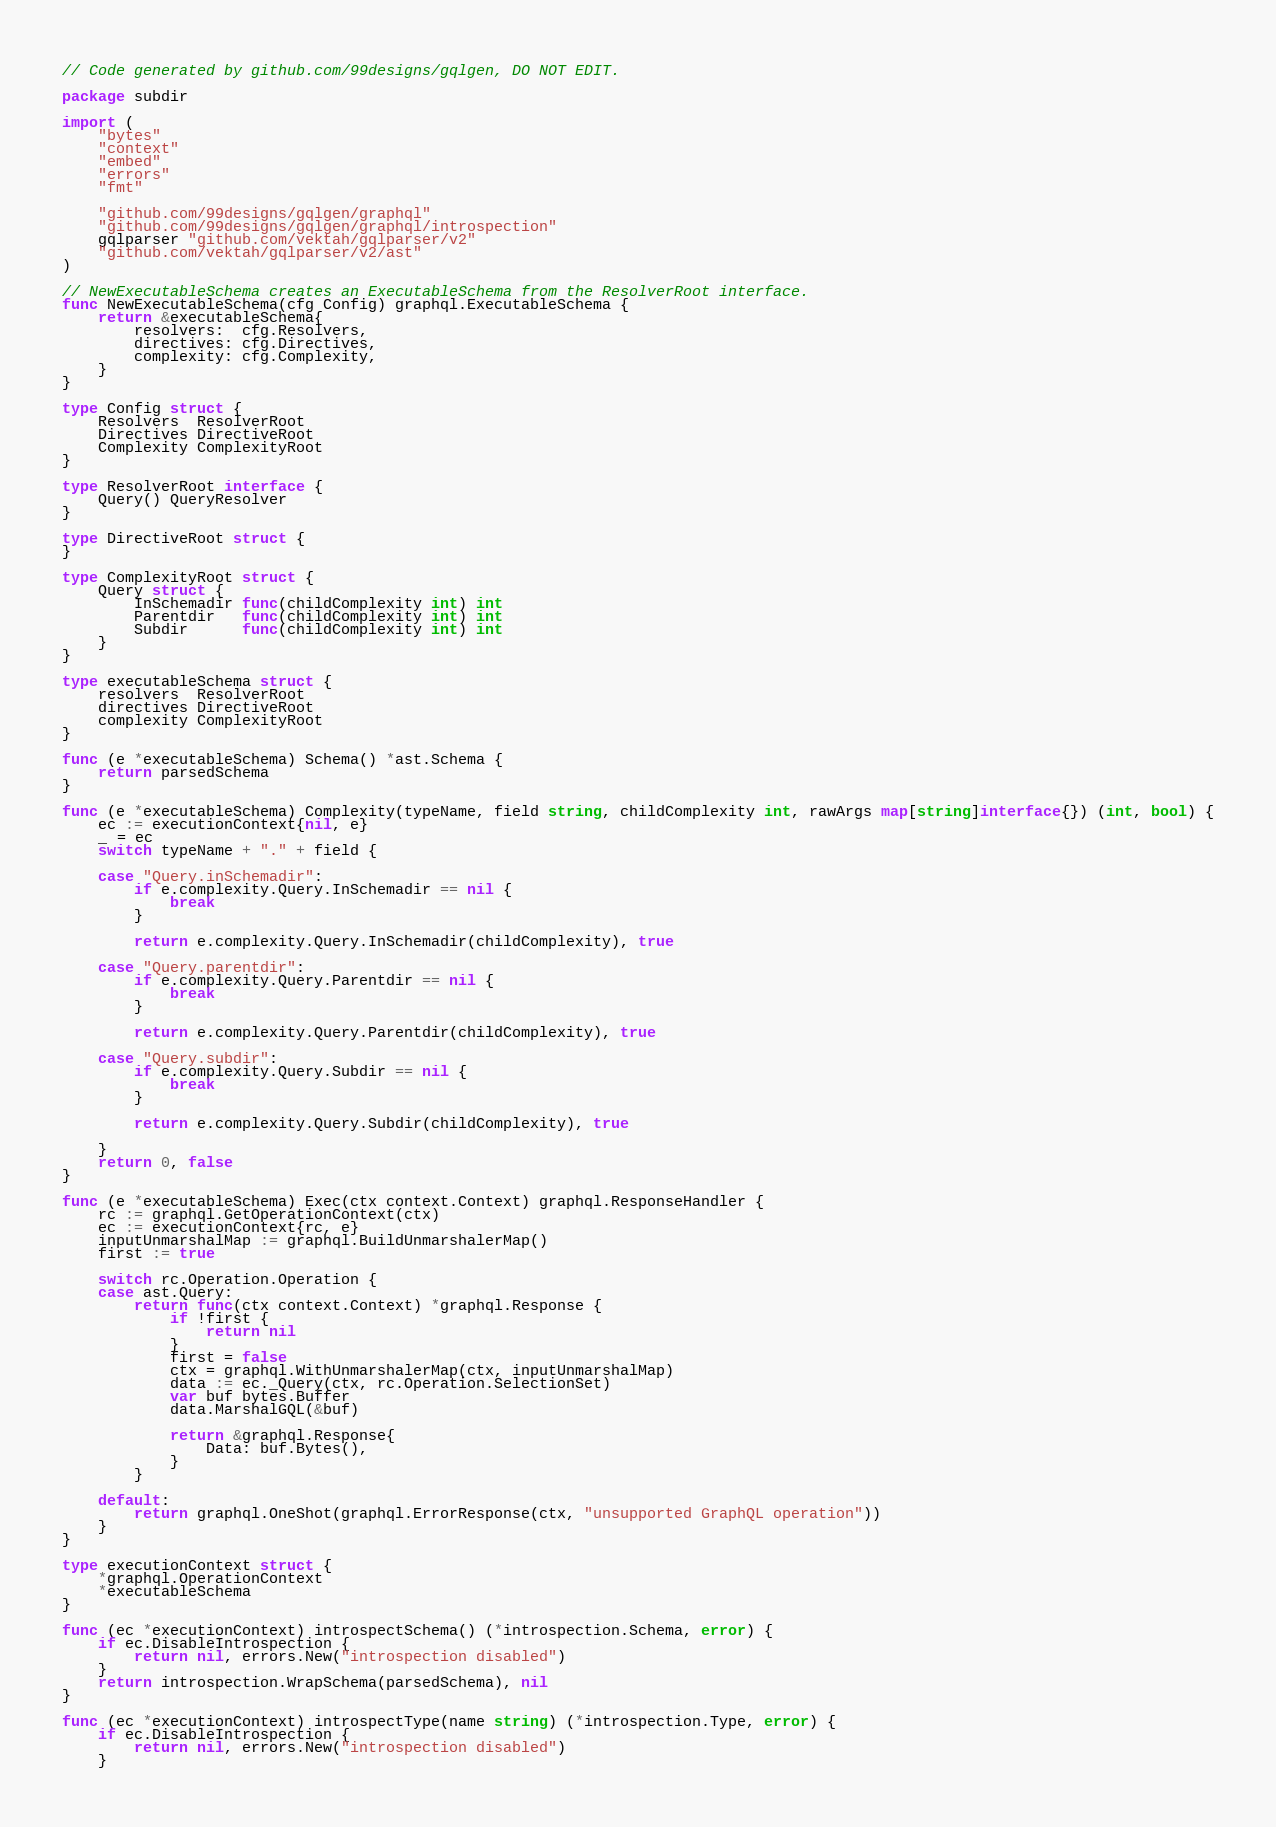<code> <loc_0><loc_0><loc_500><loc_500><_Go_>// Code generated by github.com/99designs/gqlgen, DO NOT EDIT.

package subdir

import (
	"bytes"
	"context"
	"embed"
	"errors"
	"fmt"

	"github.com/99designs/gqlgen/graphql"
	"github.com/99designs/gqlgen/graphql/introspection"
	gqlparser "github.com/vektah/gqlparser/v2"
	"github.com/vektah/gqlparser/v2/ast"
)

// NewExecutableSchema creates an ExecutableSchema from the ResolverRoot interface.
func NewExecutableSchema(cfg Config) graphql.ExecutableSchema {
	return &executableSchema{
		resolvers:  cfg.Resolvers,
		directives: cfg.Directives,
		complexity: cfg.Complexity,
	}
}

type Config struct {
	Resolvers  ResolverRoot
	Directives DirectiveRoot
	Complexity ComplexityRoot
}

type ResolverRoot interface {
	Query() QueryResolver
}

type DirectiveRoot struct {
}

type ComplexityRoot struct {
	Query struct {
		InSchemadir func(childComplexity int) int
		Parentdir   func(childComplexity int) int
		Subdir      func(childComplexity int) int
	}
}

type executableSchema struct {
	resolvers  ResolverRoot
	directives DirectiveRoot
	complexity ComplexityRoot
}

func (e *executableSchema) Schema() *ast.Schema {
	return parsedSchema
}

func (e *executableSchema) Complexity(typeName, field string, childComplexity int, rawArgs map[string]interface{}) (int, bool) {
	ec := executionContext{nil, e}
	_ = ec
	switch typeName + "." + field {

	case "Query.inSchemadir":
		if e.complexity.Query.InSchemadir == nil {
			break
		}

		return e.complexity.Query.InSchemadir(childComplexity), true

	case "Query.parentdir":
		if e.complexity.Query.Parentdir == nil {
			break
		}

		return e.complexity.Query.Parentdir(childComplexity), true

	case "Query.subdir":
		if e.complexity.Query.Subdir == nil {
			break
		}

		return e.complexity.Query.Subdir(childComplexity), true

	}
	return 0, false
}

func (e *executableSchema) Exec(ctx context.Context) graphql.ResponseHandler {
	rc := graphql.GetOperationContext(ctx)
	ec := executionContext{rc, e}
	inputUnmarshalMap := graphql.BuildUnmarshalerMap()
	first := true

	switch rc.Operation.Operation {
	case ast.Query:
		return func(ctx context.Context) *graphql.Response {
			if !first {
				return nil
			}
			first = false
			ctx = graphql.WithUnmarshalerMap(ctx, inputUnmarshalMap)
			data := ec._Query(ctx, rc.Operation.SelectionSet)
			var buf bytes.Buffer
			data.MarshalGQL(&buf)

			return &graphql.Response{
				Data: buf.Bytes(),
			}
		}

	default:
		return graphql.OneShot(graphql.ErrorResponse(ctx, "unsupported GraphQL operation"))
	}
}

type executionContext struct {
	*graphql.OperationContext
	*executableSchema
}

func (ec *executionContext) introspectSchema() (*introspection.Schema, error) {
	if ec.DisableIntrospection {
		return nil, errors.New("introspection disabled")
	}
	return introspection.WrapSchema(parsedSchema), nil
}

func (ec *executionContext) introspectType(name string) (*introspection.Type, error) {
	if ec.DisableIntrospection {
		return nil, errors.New("introspection disabled")
	}</code> 